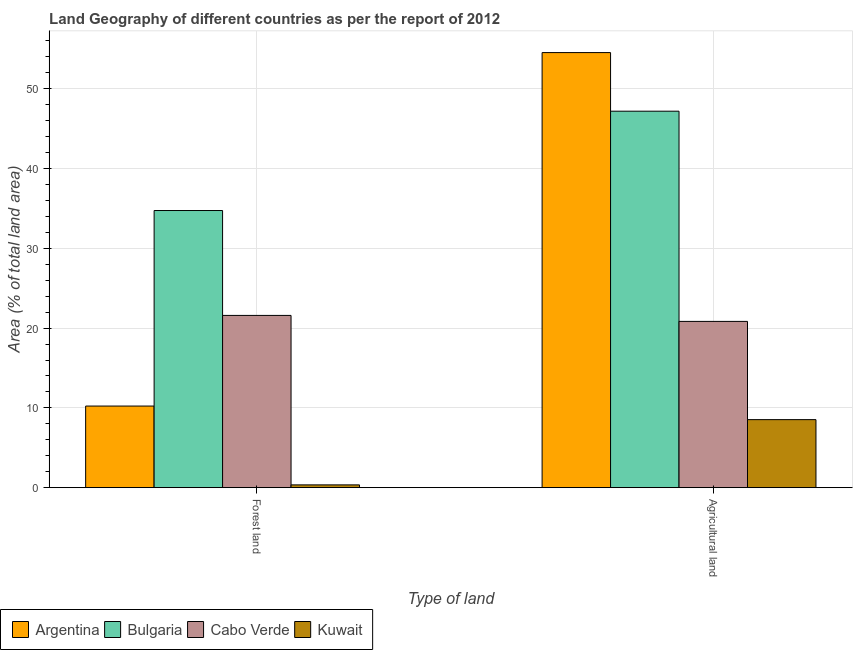How many different coloured bars are there?
Ensure brevity in your answer.  4. Are the number of bars per tick equal to the number of legend labels?
Offer a terse response. Yes. How many bars are there on the 2nd tick from the left?
Your answer should be compact. 4. How many bars are there on the 1st tick from the right?
Your response must be concise. 4. What is the label of the 2nd group of bars from the left?
Provide a succinct answer. Agricultural land. What is the percentage of land area under forests in Argentina?
Provide a succinct answer. 10.23. Across all countries, what is the maximum percentage of land area under agriculture?
Provide a succinct answer. 54.54. Across all countries, what is the minimum percentage of land area under agriculture?
Your answer should be very brief. 8.53. In which country was the percentage of land area under forests maximum?
Provide a short and direct response. Bulgaria. In which country was the percentage of land area under forests minimum?
Keep it short and to the point. Kuwait. What is the total percentage of land area under forests in the graph?
Provide a short and direct response. 66.92. What is the difference between the percentage of land area under agriculture in Cabo Verde and that in Argentina?
Ensure brevity in your answer.  -33.69. What is the difference between the percentage of land area under agriculture in Cabo Verde and the percentage of land area under forests in Argentina?
Your response must be concise. 10.61. What is the average percentage of land area under agriculture per country?
Offer a terse response. 32.78. What is the difference between the percentage of land area under agriculture and percentage of land area under forests in Cabo Verde?
Provide a short and direct response. -0.75. What is the ratio of the percentage of land area under agriculture in Argentina to that in Cabo Verde?
Ensure brevity in your answer.  2.62. In how many countries, is the percentage of land area under forests greater than the average percentage of land area under forests taken over all countries?
Offer a very short reply. 2. What does the 2nd bar from the right in Agricultural land represents?
Your answer should be compact. Cabo Verde. Are all the bars in the graph horizontal?
Keep it short and to the point. No. How many countries are there in the graph?
Provide a succinct answer. 4. What is the difference between two consecutive major ticks on the Y-axis?
Offer a terse response. 10. Does the graph contain any zero values?
Offer a terse response. No. Where does the legend appear in the graph?
Give a very brief answer. Bottom left. What is the title of the graph?
Your answer should be compact. Land Geography of different countries as per the report of 2012. What is the label or title of the X-axis?
Give a very brief answer. Type of land. What is the label or title of the Y-axis?
Provide a short and direct response. Area (% of total land area). What is the Area (% of total land area) of Argentina in Forest land?
Your answer should be very brief. 10.23. What is the Area (% of total land area) of Bulgaria in Forest land?
Offer a terse response. 34.74. What is the Area (% of total land area) of Cabo Verde in Forest land?
Offer a very short reply. 21.59. What is the Area (% of total land area) of Kuwait in Forest land?
Your answer should be compact. 0.35. What is the Area (% of total land area) of Argentina in Agricultural land?
Offer a very short reply. 54.54. What is the Area (% of total land area) in Bulgaria in Agricultural land?
Your answer should be compact. 47.19. What is the Area (% of total land area) in Cabo Verde in Agricultural land?
Ensure brevity in your answer.  20.84. What is the Area (% of total land area) of Kuwait in Agricultural land?
Make the answer very short. 8.53. Across all Type of land, what is the maximum Area (% of total land area) of Argentina?
Ensure brevity in your answer.  54.54. Across all Type of land, what is the maximum Area (% of total land area) of Bulgaria?
Provide a short and direct response. 47.19. Across all Type of land, what is the maximum Area (% of total land area) of Cabo Verde?
Provide a short and direct response. 21.59. Across all Type of land, what is the maximum Area (% of total land area) of Kuwait?
Provide a short and direct response. 8.53. Across all Type of land, what is the minimum Area (% of total land area) of Argentina?
Your answer should be compact. 10.23. Across all Type of land, what is the minimum Area (% of total land area) of Bulgaria?
Keep it short and to the point. 34.74. Across all Type of land, what is the minimum Area (% of total land area) of Cabo Verde?
Offer a very short reply. 20.84. Across all Type of land, what is the minimum Area (% of total land area) in Kuwait?
Provide a succinct answer. 0.35. What is the total Area (% of total land area) of Argentina in the graph?
Provide a succinct answer. 64.77. What is the total Area (% of total land area) in Bulgaria in the graph?
Your answer should be very brief. 81.93. What is the total Area (% of total land area) in Cabo Verde in the graph?
Your answer should be very brief. 42.44. What is the total Area (% of total land area) in Kuwait in the graph?
Your response must be concise. 8.88. What is the difference between the Area (% of total land area) of Argentina in Forest land and that in Agricultural land?
Ensure brevity in your answer.  -44.31. What is the difference between the Area (% of total land area) of Bulgaria in Forest land and that in Agricultural land?
Provide a short and direct response. -12.45. What is the difference between the Area (% of total land area) of Cabo Verde in Forest land and that in Agricultural land?
Give a very brief answer. 0.75. What is the difference between the Area (% of total land area) of Kuwait in Forest land and that in Agricultural land?
Provide a succinct answer. -8.18. What is the difference between the Area (% of total land area) in Argentina in Forest land and the Area (% of total land area) in Bulgaria in Agricultural land?
Ensure brevity in your answer.  -36.96. What is the difference between the Area (% of total land area) of Argentina in Forest land and the Area (% of total land area) of Cabo Verde in Agricultural land?
Your answer should be compact. -10.61. What is the difference between the Area (% of total land area) in Argentina in Forest land and the Area (% of total land area) in Kuwait in Agricultural land?
Provide a succinct answer. 1.7. What is the difference between the Area (% of total land area) in Bulgaria in Forest land and the Area (% of total land area) in Cabo Verde in Agricultural land?
Give a very brief answer. 13.9. What is the difference between the Area (% of total land area) in Bulgaria in Forest land and the Area (% of total land area) in Kuwait in Agricultural land?
Offer a terse response. 26.21. What is the difference between the Area (% of total land area) in Cabo Verde in Forest land and the Area (% of total land area) in Kuwait in Agricultural land?
Your answer should be very brief. 13.06. What is the average Area (% of total land area) in Argentina per Type of land?
Keep it short and to the point. 32.39. What is the average Area (% of total land area) in Bulgaria per Type of land?
Provide a short and direct response. 40.97. What is the average Area (% of total land area) in Cabo Verde per Type of land?
Your answer should be very brief. 21.22. What is the average Area (% of total land area) in Kuwait per Type of land?
Offer a terse response. 4.44. What is the difference between the Area (% of total land area) of Argentina and Area (% of total land area) of Bulgaria in Forest land?
Offer a very short reply. -24.51. What is the difference between the Area (% of total land area) in Argentina and Area (% of total land area) in Cabo Verde in Forest land?
Your answer should be very brief. -11.36. What is the difference between the Area (% of total land area) of Argentina and Area (% of total land area) of Kuwait in Forest land?
Keep it short and to the point. 9.88. What is the difference between the Area (% of total land area) in Bulgaria and Area (% of total land area) in Cabo Verde in Forest land?
Give a very brief answer. 13.15. What is the difference between the Area (% of total land area) of Bulgaria and Area (% of total land area) of Kuwait in Forest land?
Keep it short and to the point. 34.39. What is the difference between the Area (% of total land area) in Cabo Verde and Area (% of total land area) in Kuwait in Forest land?
Your response must be concise. 21.24. What is the difference between the Area (% of total land area) in Argentina and Area (% of total land area) in Bulgaria in Agricultural land?
Provide a short and direct response. 7.35. What is the difference between the Area (% of total land area) in Argentina and Area (% of total land area) in Cabo Verde in Agricultural land?
Offer a terse response. 33.69. What is the difference between the Area (% of total land area) in Argentina and Area (% of total land area) in Kuwait in Agricultural land?
Make the answer very short. 46.01. What is the difference between the Area (% of total land area) in Bulgaria and Area (% of total land area) in Cabo Verde in Agricultural land?
Ensure brevity in your answer.  26.35. What is the difference between the Area (% of total land area) of Bulgaria and Area (% of total land area) of Kuwait in Agricultural land?
Your response must be concise. 38.66. What is the difference between the Area (% of total land area) in Cabo Verde and Area (% of total land area) in Kuwait in Agricultural land?
Provide a short and direct response. 12.31. What is the ratio of the Area (% of total land area) of Argentina in Forest land to that in Agricultural land?
Give a very brief answer. 0.19. What is the ratio of the Area (% of total land area) in Bulgaria in Forest land to that in Agricultural land?
Provide a succinct answer. 0.74. What is the ratio of the Area (% of total land area) in Cabo Verde in Forest land to that in Agricultural land?
Provide a succinct answer. 1.04. What is the ratio of the Area (% of total land area) in Kuwait in Forest land to that in Agricultural land?
Provide a succinct answer. 0.04. What is the difference between the highest and the second highest Area (% of total land area) in Argentina?
Provide a short and direct response. 44.31. What is the difference between the highest and the second highest Area (% of total land area) of Bulgaria?
Make the answer very short. 12.45. What is the difference between the highest and the second highest Area (% of total land area) in Cabo Verde?
Your response must be concise. 0.75. What is the difference between the highest and the second highest Area (% of total land area) of Kuwait?
Provide a succinct answer. 8.18. What is the difference between the highest and the lowest Area (% of total land area) of Argentina?
Give a very brief answer. 44.31. What is the difference between the highest and the lowest Area (% of total land area) in Bulgaria?
Provide a succinct answer. 12.45. What is the difference between the highest and the lowest Area (% of total land area) of Cabo Verde?
Provide a short and direct response. 0.75. What is the difference between the highest and the lowest Area (% of total land area) in Kuwait?
Offer a very short reply. 8.18. 